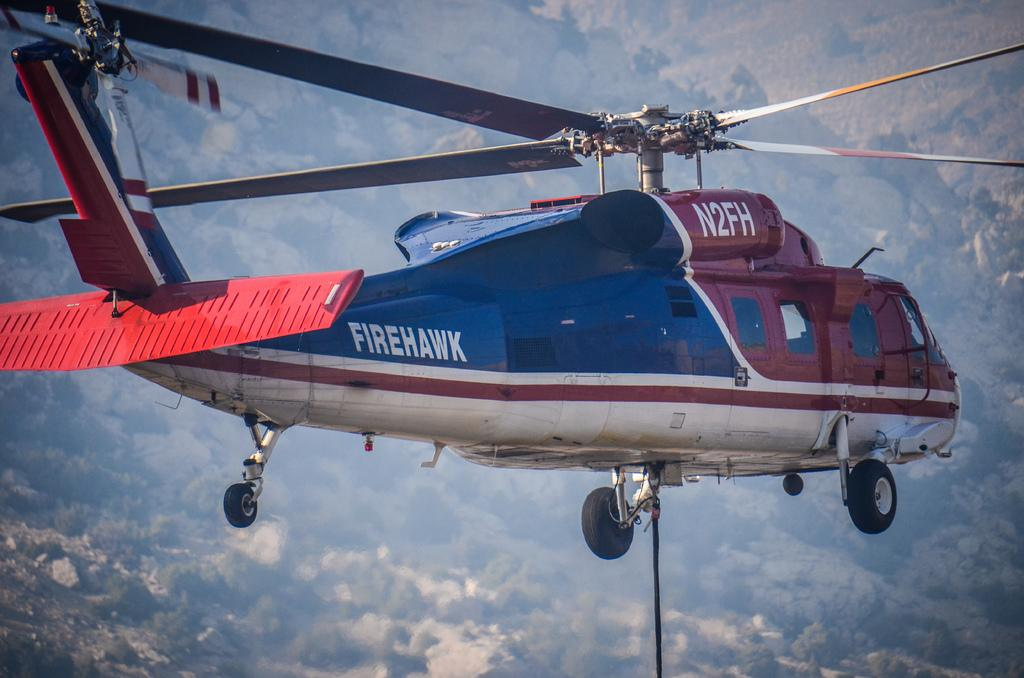<image>
Present a compact description of the photo's key features. A helicopter flying in the sky that is red on the front and blue in the back and on the back in white letters it says Firehawk. 